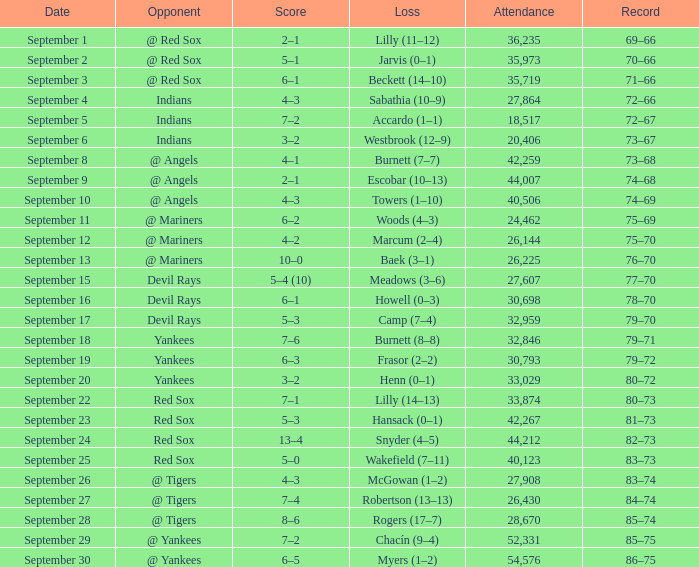Would you be able to parse every entry in this table? {'header': ['Date', 'Opponent', 'Score', 'Loss', 'Attendance', 'Record'], 'rows': [['September 1', '@ Red Sox', '2–1', 'Lilly (11–12)', '36,235', '69–66'], ['September 2', '@ Red Sox', '5–1', 'Jarvis (0–1)', '35,973', '70–66'], ['September 3', '@ Red Sox', '6–1', 'Beckett (14–10)', '35,719', '71–66'], ['September 4', 'Indians', '4–3', 'Sabathia (10–9)', '27,864', '72–66'], ['September 5', 'Indians', '7–2', 'Accardo (1–1)', '18,517', '72–67'], ['September 6', 'Indians', '3–2', 'Westbrook (12–9)', '20,406', '73–67'], ['September 8', '@ Angels', '4–1', 'Burnett (7–7)', '42,259', '73–68'], ['September 9', '@ Angels', '2–1', 'Escobar (10–13)', '44,007', '74–68'], ['September 10', '@ Angels', '4–3', 'Towers (1–10)', '40,506', '74–69'], ['September 11', '@ Mariners', '6–2', 'Woods (4–3)', '24,462', '75–69'], ['September 12', '@ Mariners', '4–2', 'Marcum (2–4)', '26,144', '75–70'], ['September 13', '@ Mariners', '10–0', 'Baek (3–1)', '26,225', '76–70'], ['September 15', 'Devil Rays', '5–4 (10)', 'Meadows (3–6)', '27,607', '77–70'], ['September 16', 'Devil Rays', '6–1', 'Howell (0–3)', '30,698', '78–70'], ['September 17', 'Devil Rays', '5–3', 'Camp (7–4)', '32,959', '79–70'], ['September 18', 'Yankees', '7–6', 'Burnett (8–8)', '32,846', '79–71'], ['September 19', 'Yankees', '6–3', 'Frasor (2–2)', '30,793', '79–72'], ['September 20', 'Yankees', '3–2', 'Henn (0–1)', '33,029', '80–72'], ['September 22', 'Red Sox', '7–1', 'Lilly (14–13)', '33,874', '80–73'], ['September 23', 'Red Sox', '5–3', 'Hansack (0–1)', '42,267', '81–73'], ['September 24', 'Red Sox', '13–4', 'Snyder (4–5)', '44,212', '82–73'], ['September 25', 'Red Sox', '5–0', 'Wakefield (7–11)', '40,123', '83–73'], ['September 26', '@ Tigers', '4–3', 'McGowan (1–2)', '27,908', '83–74'], ['September 27', '@ Tigers', '7–4', 'Robertson (13–13)', '26,430', '84–74'], ['September 28', '@ Tigers', '8–6', 'Rogers (17–7)', '28,670', '85–74'], ['September 29', '@ Yankees', '7–2', 'Chacín (9–4)', '52,331', '85–75'], ['September 30', '@ Yankees', '6–5', 'Myers (1–2)', '54,576', '86–75']]} Which rival participates on september 19? Yankees. 